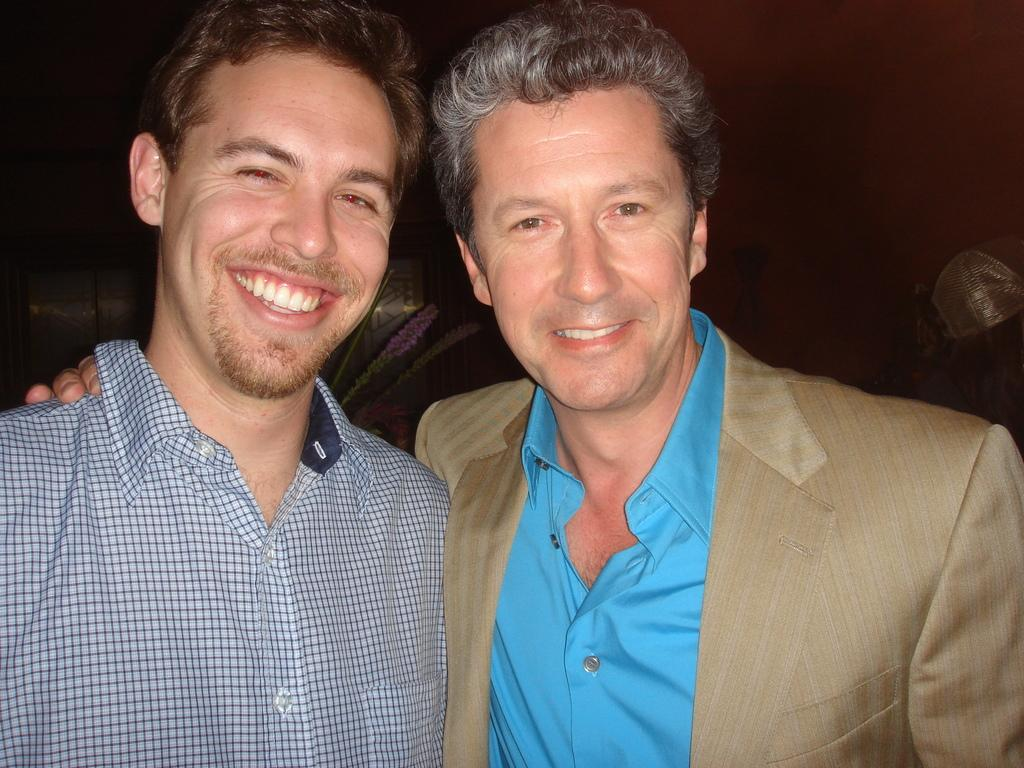How many people are in the foreground of the image? There are two men in the foreground of the image. What expressions do the men have in the image? The men are smiling in the image. What can be seen in the background of the image? There are objects and a wall in the background of the image. What idea did the men come up with while standing in the alley in the image? There is no alley present in the image, and the men's ideas are not mentioned or depicted. 